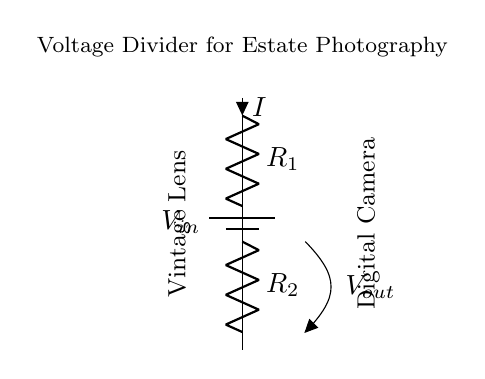What is the input voltage in the circuit? The circuit diagram indicates a power supply labeled as \( V_{in} \) which serves as the input voltage.
Answer: V_{in} What are the two resistors labeled in the circuit? The diagram shows two resistors labeled \( R_1 \) and \( R_2 \ which form the voltage divider setup.
Answer: R_1, R_2 What is the direction of the current flow in the circuit? The diagram depicts the current \( I \) flowing from the top of \( R_1 \) down through \( R_2 \) towards ground, indicating that current flows from higher to lower potential.
Answer: Downward What is the output voltage of the circuit? The output voltage \( V_{out} \) is taken across \( R_2 \), which is the voltage drop across the second resistor in the voltage divider setup.
Answer: V_{out} How does the output voltage relate to the resistances? In a voltage divider, the output voltage is derived from the formula \( V_{out} = V_{in} \times \frac{R_2}{R_1 + R_2} \), showing the relationship between input voltage and resistor values.
Answer: Voltage divider formula Why is a voltage divider used in this circuit? A voltage divider is used to reduce the input voltage to a suitable level for interfacing vintage camera lenses with modern digital camera bodies, ensuring compatibility and preventing damage.
Answer: For voltage level adjustment What do \( R_1 \) and \( R_2 \) represent in this application? In this context, \( R_1 \) and \( R_2 \) represent resistances used to create a specific voltage level that matches the requirements of the digital camera body's input, crucial for successful interfacing.
Answer: Resistance values for interfacing 